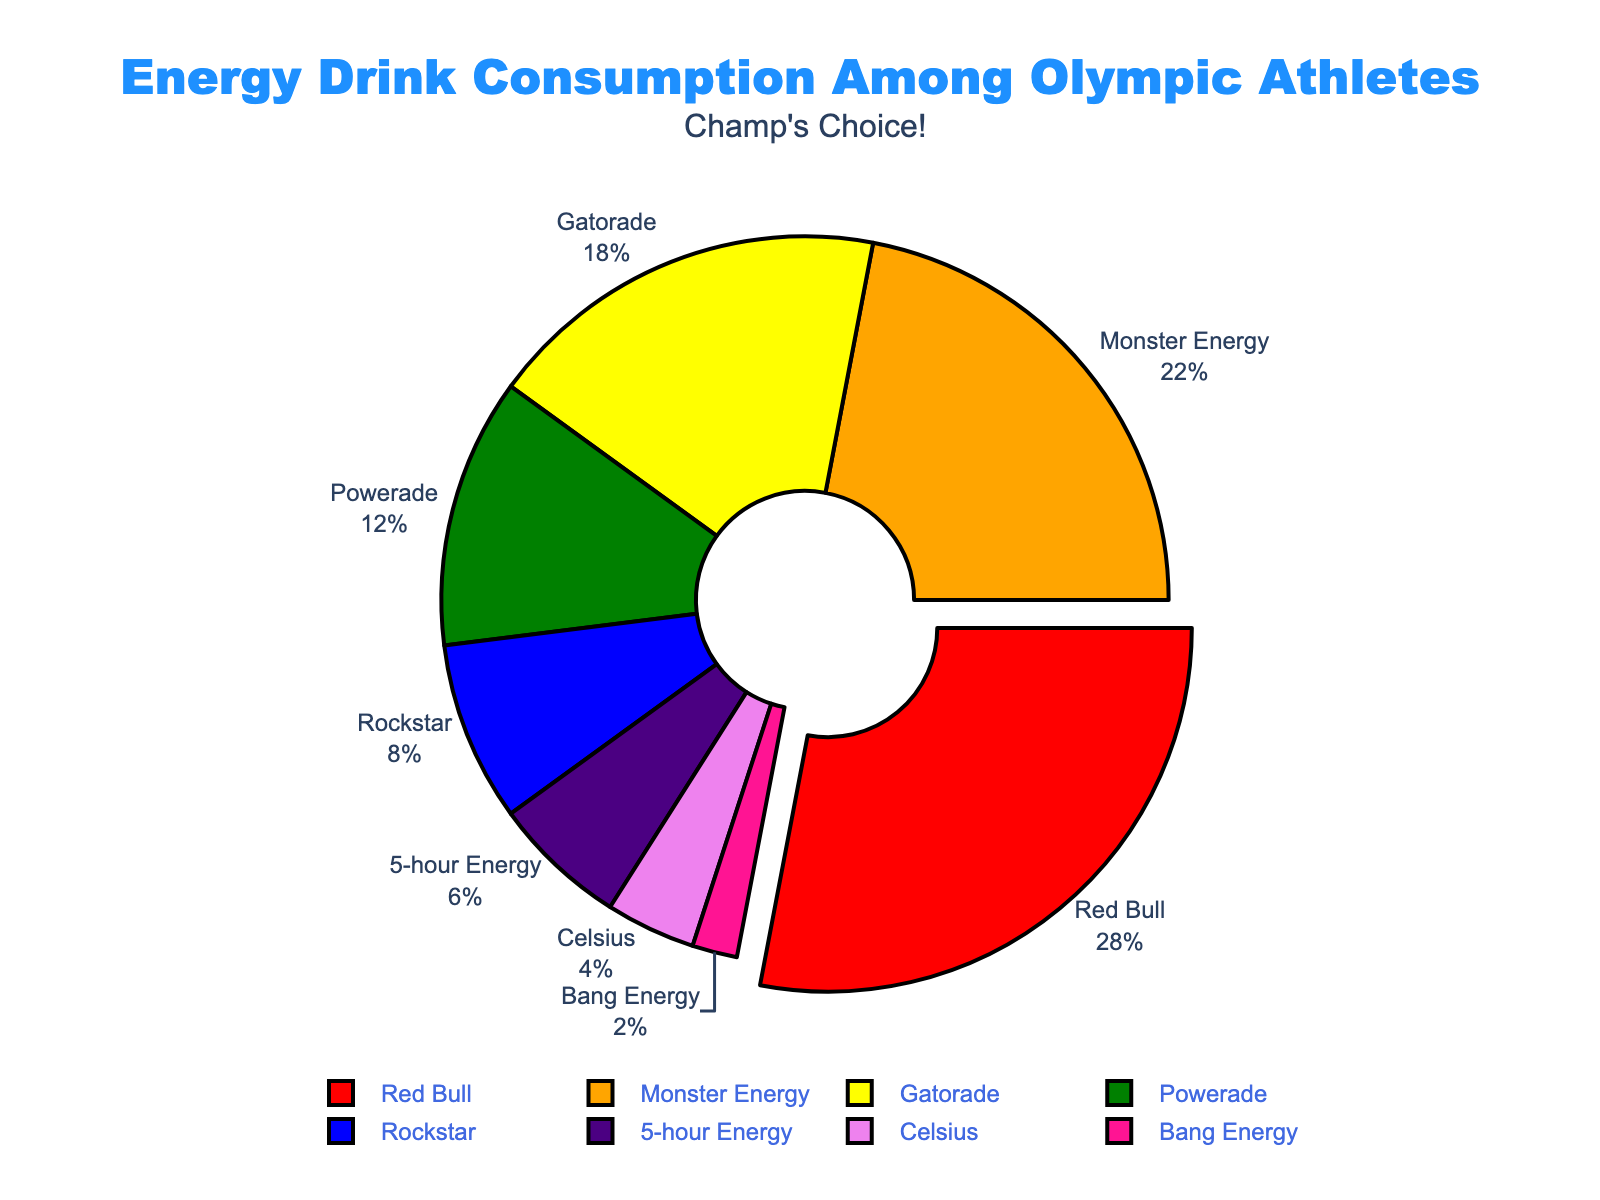What percentage of athletes consume Monster Energy? The section labeled "Monster Energy" shows the exact percentage.
Answer: 22 Which energy drink is the most consumed among Olympic athletes? The largest segment of the pie chart or the segment pulled out from the rest represents the most consumed energy drink. The "Red Bull" segment is the largest and pulled out, indicating it is the most consumed.
Answer: Red Bull What is the combined percentage of athletes who consume Powerade, Rockstar, and 5-hour Energy? Add the percentages for Powerade, Rockstar, and 5-hour Energy. Powerade is 12%, Rockstar is 8%, and 5-hour Energy is 6%. The combined percentage is 12 + 8 + 6 = 26%.
Answer: 26% Is Gatorade more or less consumed than Monster Energy, and by how much? Subtract the percentage of Monster Energy from the percentage of Gatorade. Gatorade has 18%, and Monster Energy has 22%. The difference is 22 - 18 = 4%.
Answer: Less by 4% Identify the drinks consuming less than 10% of the athletes. Examine the labels and percentages in the pie chart for values under 10%. These segments are Rockstar (8%), 5-hour Energy (6%), Celsius (4%), and Bang Energy (2%).
Answer: Rockstar, 5-hour Energy, Celsius, Bang Energy By what percentage does Red Bull exceed the second most consumed energy drink? Subtract the percentage of the second most consumed drink (Monster Energy, 22%) from Red Bull's percentage (28%). 28 - 22 = 6%.
Answer: 6% What visual feature is used to highlight the most consumed energy drink? Observe the visual annotations, specifically focusing on the slice that stands out. Red Bull slice is 'pulled out' from the pie chart.
Answer: Slice is pulled out What is the sum percentage of the least three consumed energy drinks? Identify and add up the percentages of Bang Energy (2%), Celsius (4%), and 5-hour Energy (6%). The sum is 2 + 4 + 6 = 12%.
Answer: 12% How much more popular is Red Bull compared to Bang Energy in terms of percentage points? Subtract the percentage of Bang Energy (2%) from Red Bull (28%). The difference is 28 - 2 = 26%.
Answer: 26% What color is the segment representing Gatorade in the chart? Look at the pie chart and match the segment labeled "Gatorade" to its color. The Gatorade segment is yellow.
Answer: Yellow 